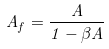<formula> <loc_0><loc_0><loc_500><loc_500>A _ { f } = \frac { A } { 1 - \beta A }</formula> 